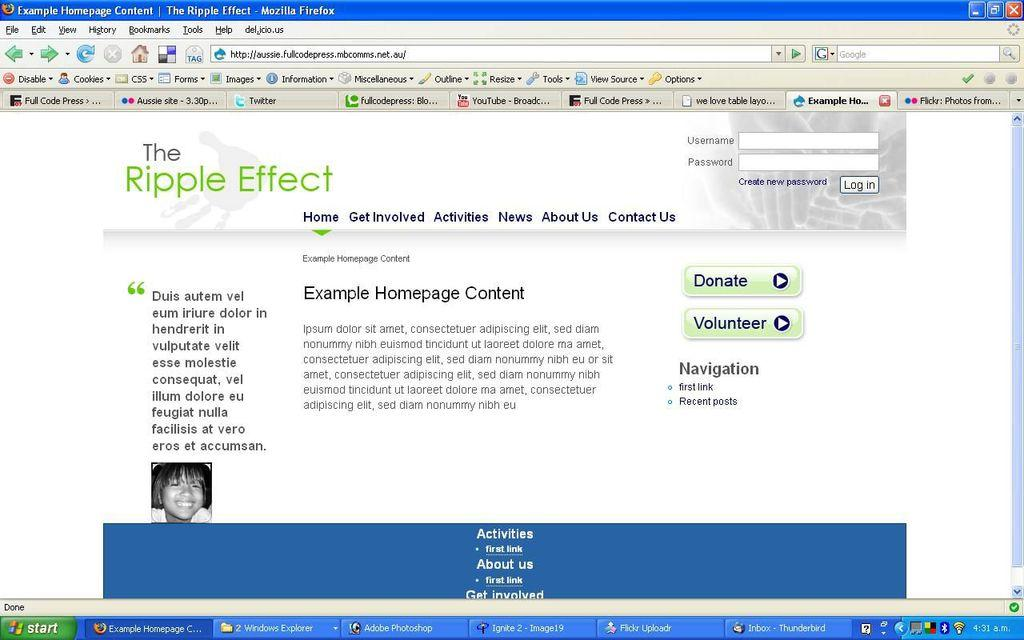<image>
Write a terse but informative summary of the picture. Computer screen showing The Ripple Effect on it. 